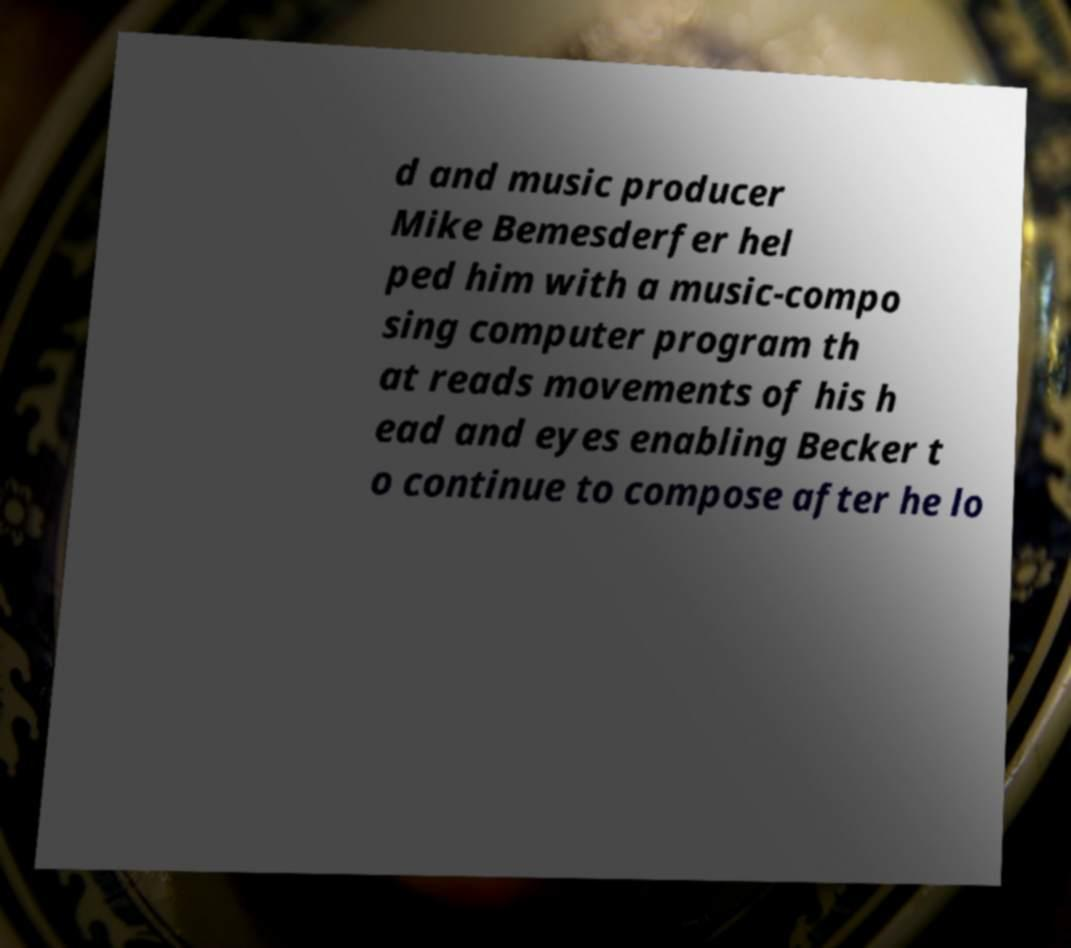Please identify and transcribe the text found in this image. d and music producer Mike Bemesderfer hel ped him with a music-compo sing computer program th at reads movements of his h ead and eyes enabling Becker t o continue to compose after he lo 